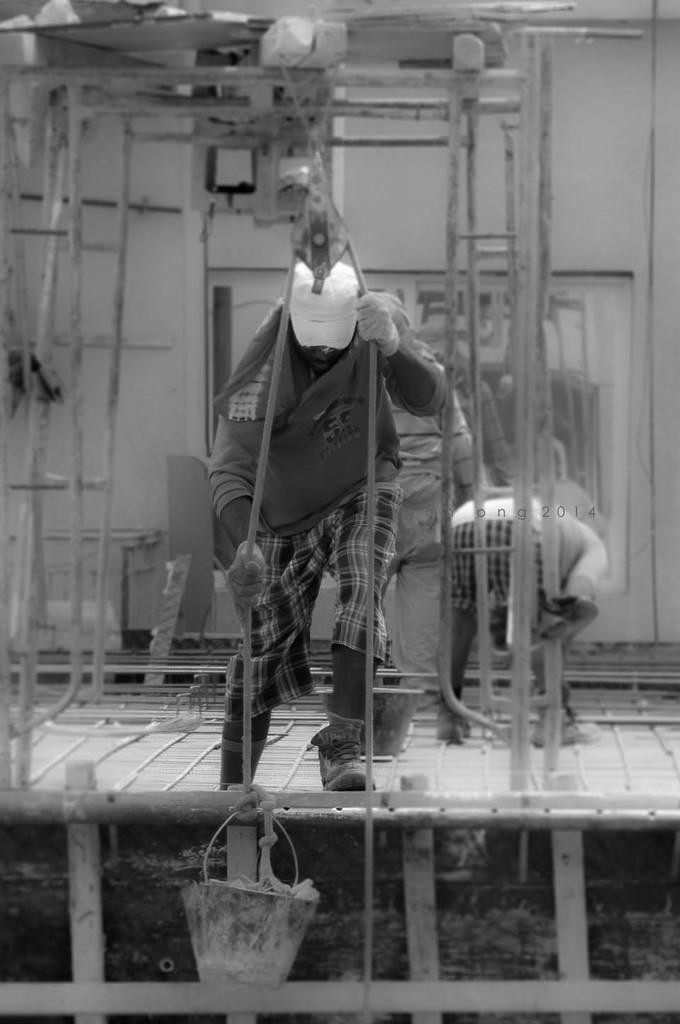What is the person in the image doing? The person in the image is pulling a bucket. How is the bucket connected to the person? The bucket is connected to a rope. Can you describe the people in the background of the image? There are people visible in the background of the image. What is the color scheme of the image? The image is in black and white. What type of cabbage is being used as a rhythm instrument in the image? There is no cabbage or rhythm instrument present in the image. What is the minister doing in the image? There is no minister present in the image. 